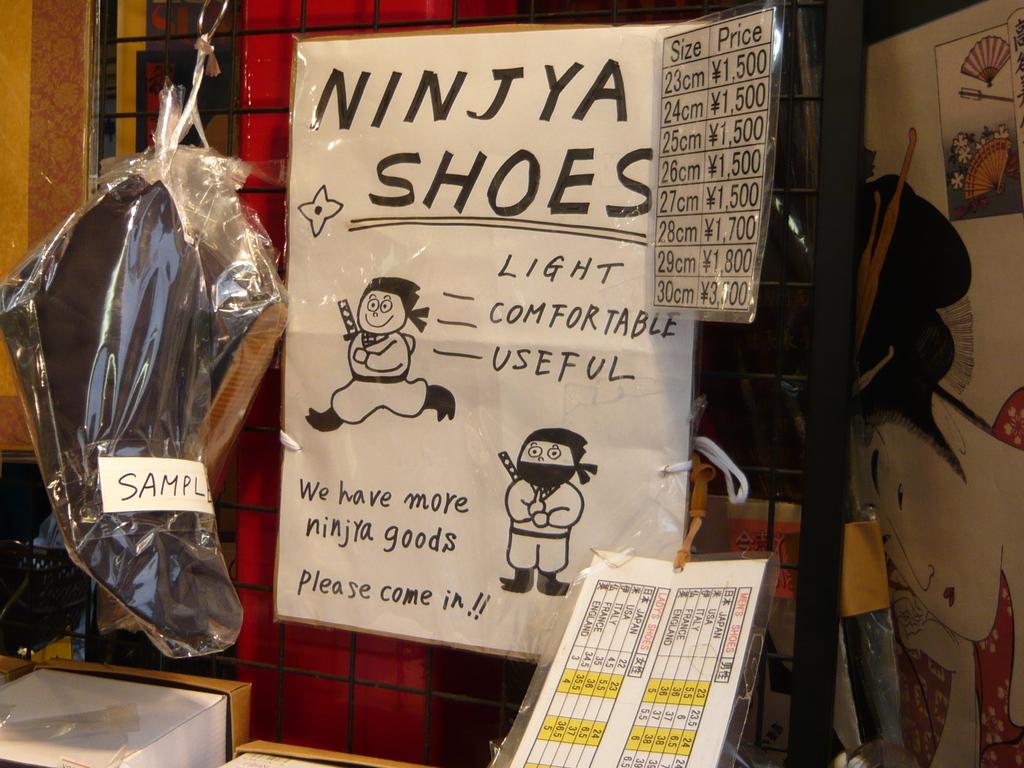Which country does  ninjya shoes originate  from?
Provide a succinct answer. Unanswerable. 